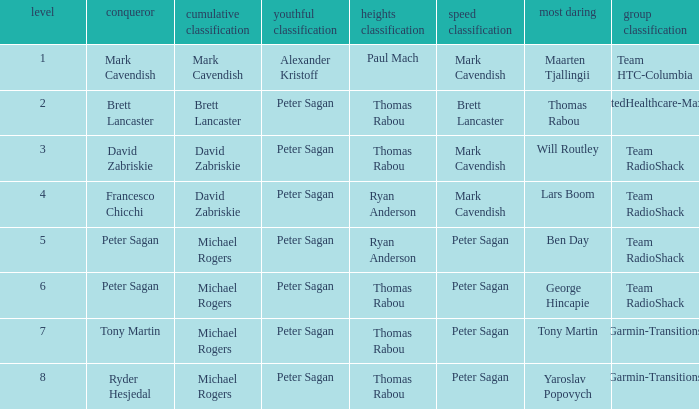Who was the winner of the sprint classification when peter sagan secured the youth classification and thomas rabou claimed the most courageous title? Brett Lancaster. 